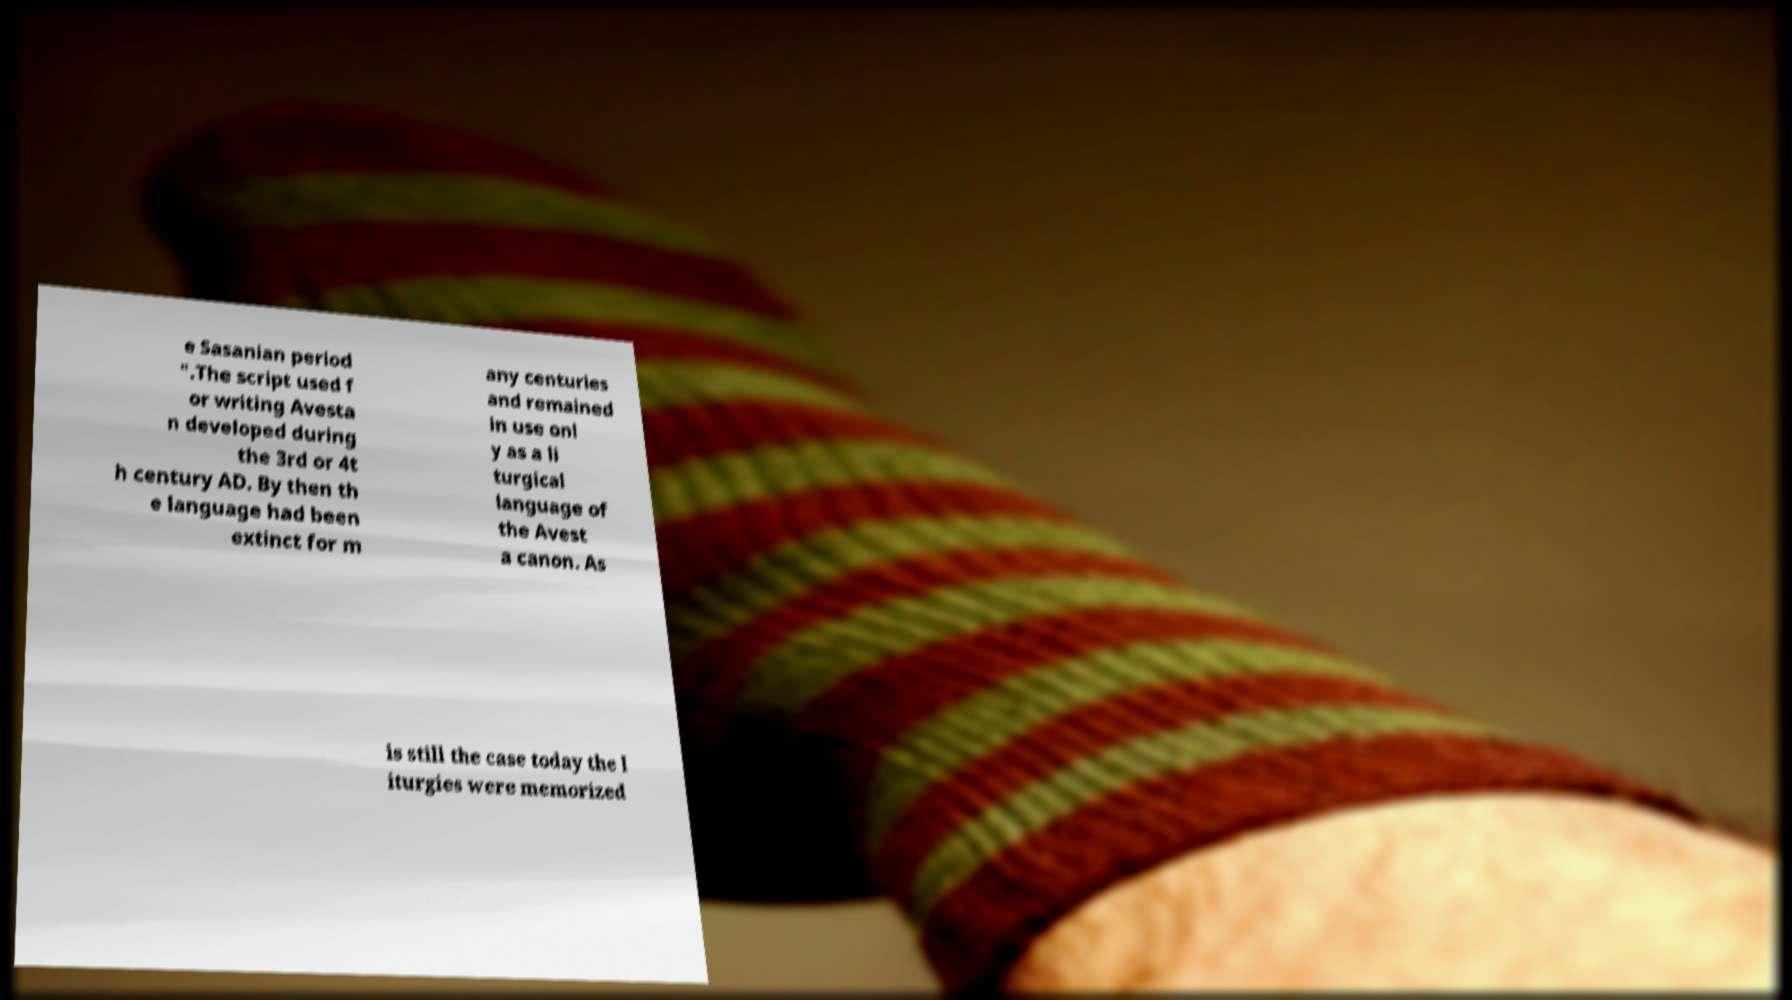Can you accurately transcribe the text from the provided image for me? e Sasanian period ".The script used f or writing Avesta n developed during the 3rd or 4t h century AD. By then th e language had been extinct for m any centuries and remained in use onl y as a li turgical language of the Avest a canon. As is still the case today the l iturgies were memorized 